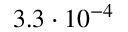<formula> <loc_0><loc_0><loc_500><loc_500>3 . 3 \cdot 1 0 ^ { - 4 }</formula> 